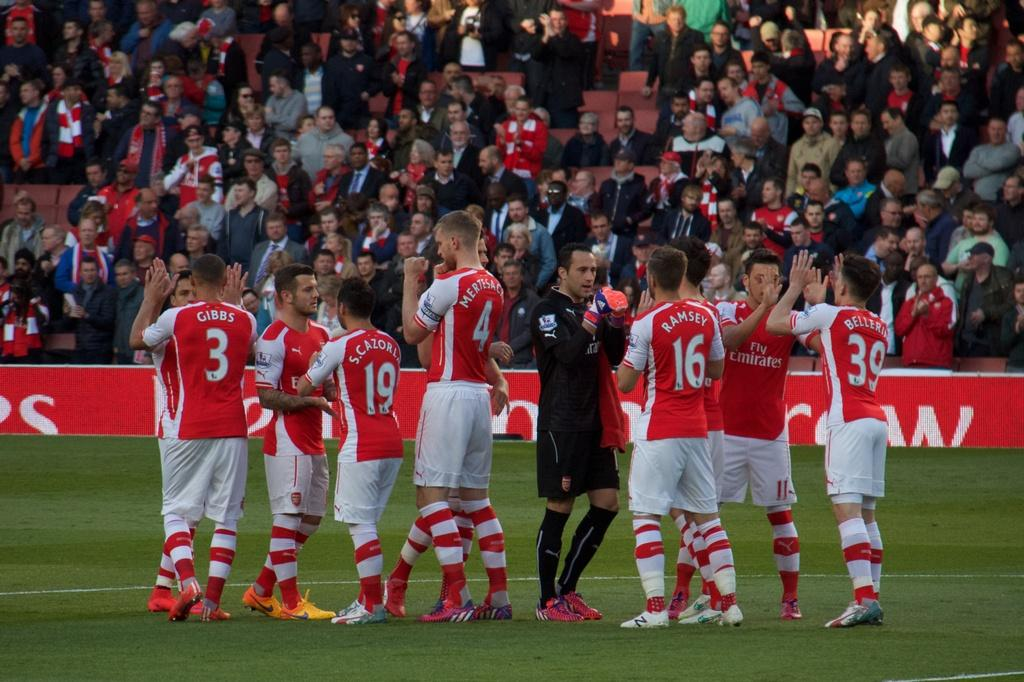<image>
Create a compact narrative representing the image presented. A soccer team that has a player named Ramsey are on a soccer field. 